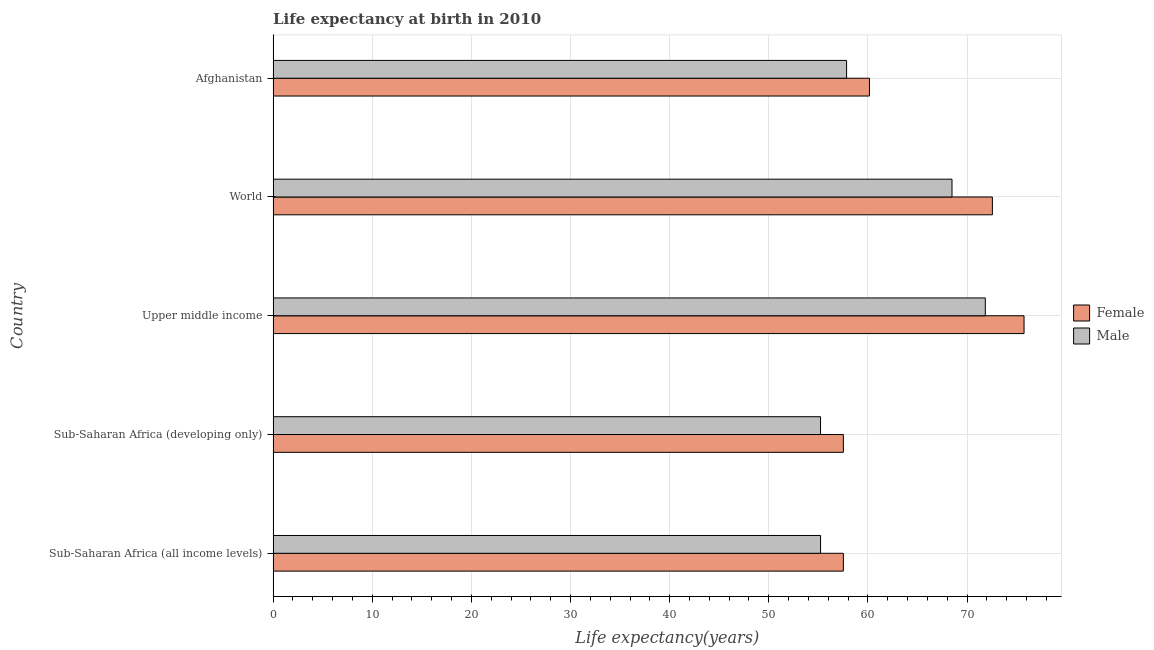How many different coloured bars are there?
Make the answer very short. 2. How many bars are there on the 2nd tick from the top?
Ensure brevity in your answer.  2. How many bars are there on the 5th tick from the bottom?
Provide a succinct answer. 2. What is the label of the 5th group of bars from the top?
Offer a terse response. Sub-Saharan Africa (all income levels). In how many cases, is the number of bars for a given country not equal to the number of legend labels?
Offer a terse response. 0. What is the life expectancy(male) in Upper middle income?
Ensure brevity in your answer.  71.84. Across all countries, what is the maximum life expectancy(male)?
Offer a very short reply. 71.84. Across all countries, what is the minimum life expectancy(female)?
Your answer should be compact. 57.52. In which country was the life expectancy(female) maximum?
Give a very brief answer. Upper middle income. In which country was the life expectancy(female) minimum?
Offer a terse response. Sub-Saharan Africa (developing only). What is the total life expectancy(male) in the graph?
Keep it short and to the point. 308.6. What is the difference between the life expectancy(female) in Sub-Saharan Africa (all income levels) and that in Sub-Saharan Africa (developing only)?
Keep it short and to the point. 0. What is the difference between the life expectancy(male) in Sub-Saharan Africa (all income levels) and the life expectancy(female) in Afghanistan?
Your answer should be compact. -4.94. What is the average life expectancy(male) per country?
Your answer should be compact. 61.72. What is the difference between the life expectancy(female) and life expectancy(male) in Upper middle income?
Provide a short and direct response. 3.91. In how many countries, is the life expectancy(female) greater than 34 years?
Keep it short and to the point. 5. What is the ratio of the life expectancy(female) in Sub-Saharan Africa (developing only) to that in World?
Offer a very short reply. 0.79. Is the difference between the life expectancy(male) in Sub-Saharan Africa (all income levels) and Sub-Saharan Africa (developing only) greater than the difference between the life expectancy(female) in Sub-Saharan Africa (all income levels) and Sub-Saharan Africa (developing only)?
Keep it short and to the point. No. What is the difference between the highest and the second highest life expectancy(male)?
Keep it short and to the point. 3.36. What is the difference between the highest and the lowest life expectancy(male)?
Your response must be concise. 16.62. In how many countries, is the life expectancy(female) greater than the average life expectancy(female) taken over all countries?
Keep it short and to the point. 2. Is the sum of the life expectancy(male) in Sub-Saharan Africa (developing only) and World greater than the maximum life expectancy(female) across all countries?
Keep it short and to the point. Yes. What does the 2nd bar from the top in Sub-Saharan Africa (developing only) represents?
Your answer should be very brief. Female. What does the 2nd bar from the bottom in Upper middle income represents?
Make the answer very short. Male. How many bars are there?
Your response must be concise. 10. Are all the bars in the graph horizontal?
Ensure brevity in your answer.  Yes. Are the values on the major ticks of X-axis written in scientific E-notation?
Offer a very short reply. No. Where does the legend appear in the graph?
Your answer should be compact. Center right. How are the legend labels stacked?
Keep it short and to the point. Vertical. What is the title of the graph?
Your answer should be compact. Life expectancy at birth in 2010. What is the label or title of the X-axis?
Offer a terse response. Life expectancy(years). What is the Life expectancy(years) in Female in Sub-Saharan Africa (all income levels)?
Offer a terse response. 57.52. What is the Life expectancy(years) of Male in Sub-Saharan Africa (all income levels)?
Provide a succinct answer. 55.22. What is the Life expectancy(years) of Female in Sub-Saharan Africa (developing only)?
Keep it short and to the point. 57.52. What is the Life expectancy(years) in Male in Sub-Saharan Africa (developing only)?
Keep it short and to the point. 55.22. What is the Life expectancy(years) in Female in Upper middle income?
Make the answer very short. 75.75. What is the Life expectancy(years) of Male in Upper middle income?
Give a very brief answer. 71.84. What is the Life expectancy(years) in Female in World?
Offer a terse response. 72.55. What is the Life expectancy(years) of Male in World?
Provide a short and direct response. 68.48. What is the Life expectancy(years) of Female in Afghanistan?
Your answer should be very brief. 60.15. What is the Life expectancy(years) in Male in Afghanistan?
Offer a very short reply. 57.84. Across all countries, what is the maximum Life expectancy(years) of Female?
Ensure brevity in your answer.  75.75. Across all countries, what is the maximum Life expectancy(years) of Male?
Your answer should be compact. 71.84. Across all countries, what is the minimum Life expectancy(years) in Female?
Provide a succinct answer. 57.52. Across all countries, what is the minimum Life expectancy(years) of Male?
Ensure brevity in your answer.  55.22. What is the total Life expectancy(years) in Female in the graph?
Your answer should be compact. 323.49. What is the total Life expectancy(years) in Male in the graph?
Offer a very short reply. 308.6. What is the difference between the Life expectancy(years) of Female in Sub-Saharan Africa (all income levels) and that in Sub-Saharan Africa (developing only)?
Ensure brevity in your answer.  0. What is the difference between the Life expectancy(years) in Female in Sub-Saharan Africa (all income levels) and that in Upper middle income?
Offer a terse response. -18.22. What is the difference between the Life expectancy(years) of Male in Sub-Saharan Africa (all income levels) and that in Upper middle income?
Your answer should be very brief. -16.62. What is the difference between the Life expectancy(years) in Female in Sub-Saharan Africa (all income levels) and that in World?
Make the answer very short. -15.03. What is the difference between the Life expectancy(years) in Male in Sub-Saharan Africa (all income levels) and that in World?
Provide a succinct answer. -13.26. What is the difference between the Life expectancy(years) in Female in Sub-Saharan Africa (all income levels) and that in Afghanistan?
Your response must be concise. -2.63. What is the difference between the Life expectancy(years) in Male in Sub-Saharan Africa (all income levels) and that in Afghanistan?
Offer a terse response. -2.63. What is the difference between the Life expectancy(years) of Female in Sub-Saharan Africa (developing only) and that in Upper middle income?
Your answer should be compact. -18.23. What is the difference between the Life expectancy(years) in Male in Sub-Saharan Africa (developing only) and that in Upper middle income?
Your answer should be compact. -16.62. What is the difference between the Life expectancy(years) of Female in Sub-Saharan Africa (developing only) and that in World?
Make the answer very short. -15.03. What is the difference between the Life expectancy(years) in Male in Sub-Saharan Africa (developing only) and that in World?
Keep it short and to the point. -13.26. What is the difference between the Life expectancy(years) in Female in Sub-Saharan Africa (developing only) and that in Afghanistan?
Your answer should be compact. -2.63. What is the difference between the Life expectancy(years) of Male in Sub-Saharan Africa (developing only) and that in Afghanistan?
Your response must be concise. -2.63. What is the difference between the Life expectancy(years) in Female in Upper middle income and that in World?
Keep it short and to the point. 3.19. What is the difference between the Life expectancy(years) of Male in Upper middle income and that in World?
Your answer should be very brief. 3.36. What is the difference between the Life expectancy(years) in Female in Upper middle income and that in Afghanistan?
Your answer should be very brief. 15.59. What is the difference between the Life expectancy(years) in Male in Upper middle income and that in Afghanistan?
Provide a short and direct response. 14. What is the difference between the Life expectancy(years) in Female in World and that in Afghanistan?
Give a very brief answer. 12.4. What is the difference between the Life expectancy(years) of Male in World and that in Afghanistan?
Keep it short and to the point. 10.64. What is the difference between the Life expectancy(years) in Female in Sub-Saharan Africa (all income levels) and the Life expectancy(years) in Male in Sub-Saharan Africa (developing only)?
Make the answer very short. 2.3. What is the difference between the Life expectancy(years) in Female in Sub-Saharan Africa (all income levels) and the Life expectancy(years) in Male in Upper middle income?
Give a very brief answer. -14.32. What is the difference between the Life expectancy(years) in Female in Sub-Saharan Africa (all income levels) and the Life expectancy(years) in Male in World?
Provide a succinct answer. -10.96. What is the difference between the Life expectancy(years) in Female in Sub-Saharan Africa (all income levels) and the Life expectancy(years) in Male in Afghanistan?
Offer a terse response. -0.32. What is the difference between the Life expectancy(years) in Female in Sub-Saharan Africa (developing only) and the Life expectancy(years) in Male in Upper middle income?
Ensure brevity in your answer.  -14.32. What is the difference between the Life expectancy(years) of Female in Sub-Saharan Africa (developing only) and the Life expectancy(years) of Male in World?
Offer a terse response. -10.96. What is the difference between the Life expectancy(years) in Female in Sub-Saharan Africa (developing only) and the Life expectancy(years) in Male in Afghanistan?
Keep it short and to the point. -0.32. What is the difference between the Life expectancy(years) in Female in Upper middle income and the Life expectancy(years) in Male in World?
Offer a very short reply. 7.27. What is the difference between the Life expectancy(years) of Female in Upper middle income and the Life expectancy(years) of Male in Afghanistan?
Your answer should be very brief. 17.9. What is the difference between the Life expectancy(years) of Female in World and the Life expectancy(years) of Male in Afghanistan?
Make the answer very short. 14.71. What is the average Life expectancy(years) of Female per country?
Ensure brevity in your answer.  64.7. What is the average Life expectancy(years) of Male per country?
Offer a terse response. 61.72. What is the difference between the Life expectancy(years) in Female and Life expectancy(years) in Male in Sub-Saharan Africa (all income levels)?
Provide a succinct answer. 2.3. What is the difference between the Life expectancy(years) of Female and Life expectancy(years) of Male in Sub-Saharan Africa (developing only)?
Offer a very short reply. 2.3. What is the difference between the Life expectancy(years) in Female and Life expectancy(years) in Male in Upper middle income?
Provide a short and direct response. 3.91. What is the difference between the Life expectancy(years) of Female and Life expectancy(years) of Male in World?
Ensure brevity in your answer.  4.07. What is the difference between the Life expectancy(years) of Female and Life expectancy(years) of Male in Afghanistan?
Keep it short and to the point. 2.31. What is the ratio of the Life expectancy(years) in Female in Sub-Saharan Africa (all income levels) to that in Sub-Saharan Africa (developing only)?
Your response must be concise. 1. What is the ratio of the Life expectancy(years) in Male in Sub-Saharan Africa (all income levels) to that in Sub-Saharan Africa (developing only)?
Your answer should be very brief. 1. What is the ratio of the Life expectancy(years) of Female in Sub-Saharan Africa (all income levels) to that in Upper middle income?
Keep it short and to the point. 0.76. What is the ratio of the Life expectancy(years) of Male in Sub-Saharan Africa (all income levels) to that in Upper middle income?
Your response must be concise. 0.77. What is the ratio of the Life expectancy(years) of Female in Sub-Saharan Africa (all income levels) to that in World?
Ensure brevity in your answer.  0.79. What is the ratio of the Life expectancy(years) of Male in Sub-Saharan Africa (all income levels) to that in World?
Offer a very short reply. 0.81. What is the ratio of the Life expectancy(years) of Female in Sub-Saharan Africa (all income levels) to that in Afghanistan?
Provide a short and direct response. 0.96. What is the ratio of the Life expectancy(years) of Male in Sub-Saharan Africa (all income levels) to that in Afghanistan?
Make the answer very short. 0.95. What is the ratio of the Life expectancy(years) of Female in Sub-Saharan Africa (developing only) to that in Upper middle income?
Your answer should be very brief. 0.76. What is the ratio of the Life expectancy(years) in Male in Sub-Saharan Africa (developing only) to that in Upper middle income?
Make the answer very short. 0.77. What is the ratio of the Life expectancy(years) in Female in Sub-Saharan Africa (developing only) to that in World?
Your answer should be very brief. 0.79. What is the ratio of the Life expectancy(years) in Male in Sub-Saharan Africa (developing only) to that in World?
Ensure brevity in your answer.  0.81. What is the ratio of the Life expectancy(years) in Female in Sub-Saharan Africa (developing only) to that in Afghanistan?
Ensure brevity in your answer.  0.96. What is the ratio of the Life expectancy(years) in Male in Sub-Saharan Africa (developing only) to that in Afghanistan?
Provide a succinct answer. 0.95. What is the ratio of the Life expectancy(years) in Female in Upper middle income to that in World?
Ensure brevity in your answer.  1.04. What is the ratio of the Life expectancy(years) of Male in Upper middle income to that in World?
Your response must be concise. 1.05. What is the ratio of the Life expectancy(years) of Female in Upper middle income to that in Afghanistan?
Give a very brief answer. 1.26. What is the ratio of the Life expectancy(years) in Male in Upper middle income to that in Afghanistan?
Your answer should be very brief. 1.24. What is the ratio of the Life expectancy(years) in Female in World to that in Afghanistan?
Your response must be concise. 1.21. What is the ratio of the Life expectancy(years) of Male in World to that in Afghanistan?
Ensure brevity in your answer.  1.18. What is the difference between the highest and the second highest Life expectancy(years) of Female?
Ensure brevity in your answer.  3.19. What is the difference between the highest and the second highest Life expectancy(years) of Male?
Your response must be concise. 3.36. What is the difference between the highest and the lowest Life expectancy(years) of Female?
Offer a very short reply. 18.23. What is the difference between the highest and the lowest Life expectancy(years) in Male?
Your answer should be compact. 16.62. 